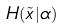<formula> <loc_0><loc_0><loc_500><loc_500>H ( \tilde { x } | \alpha )</formula> 